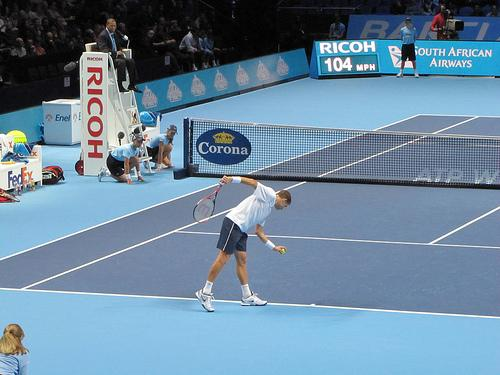How fast did the displayed speed indicator show? The displayed speed indicator shows 104 mph. What is the connection between the man holding a camera and a man wearing a red shirt? The man wearing a red shirt is a camera man holding a TV camera. What item of clothing is the tennis player wearing that is of a white color? The tennis player is wearing a white athletic t-shirt. Identify the object being advertised on the tennis net. The object being advertised on the tennis net is Corona beer. What activity are the two people under the elevated seat engaged in? The two people under the elevated seat are kneeling, possibly ready to sprint. Give a humorous spin to the image description. A determined tennis player tries to serve the game of his life while the referee, bit by the fashion bug, goes on a quest to find the perfect suit amidst numerous distractions, including an impressive display of advertisements and an army of curious spectators. What two things identify the woman on the side of the tennis court? The woman on the side of the tennis court has blond hair and is sitting. Mention the object a man is holding in his hand and its color. A man is holding a yellow tennis ball in his hand. How is the referee being distinguished from the rest in the image? The referee is distinguished by wearing a suit and sitting in a high chair. In a word, what type of event is happening in the image? A tennis match. 